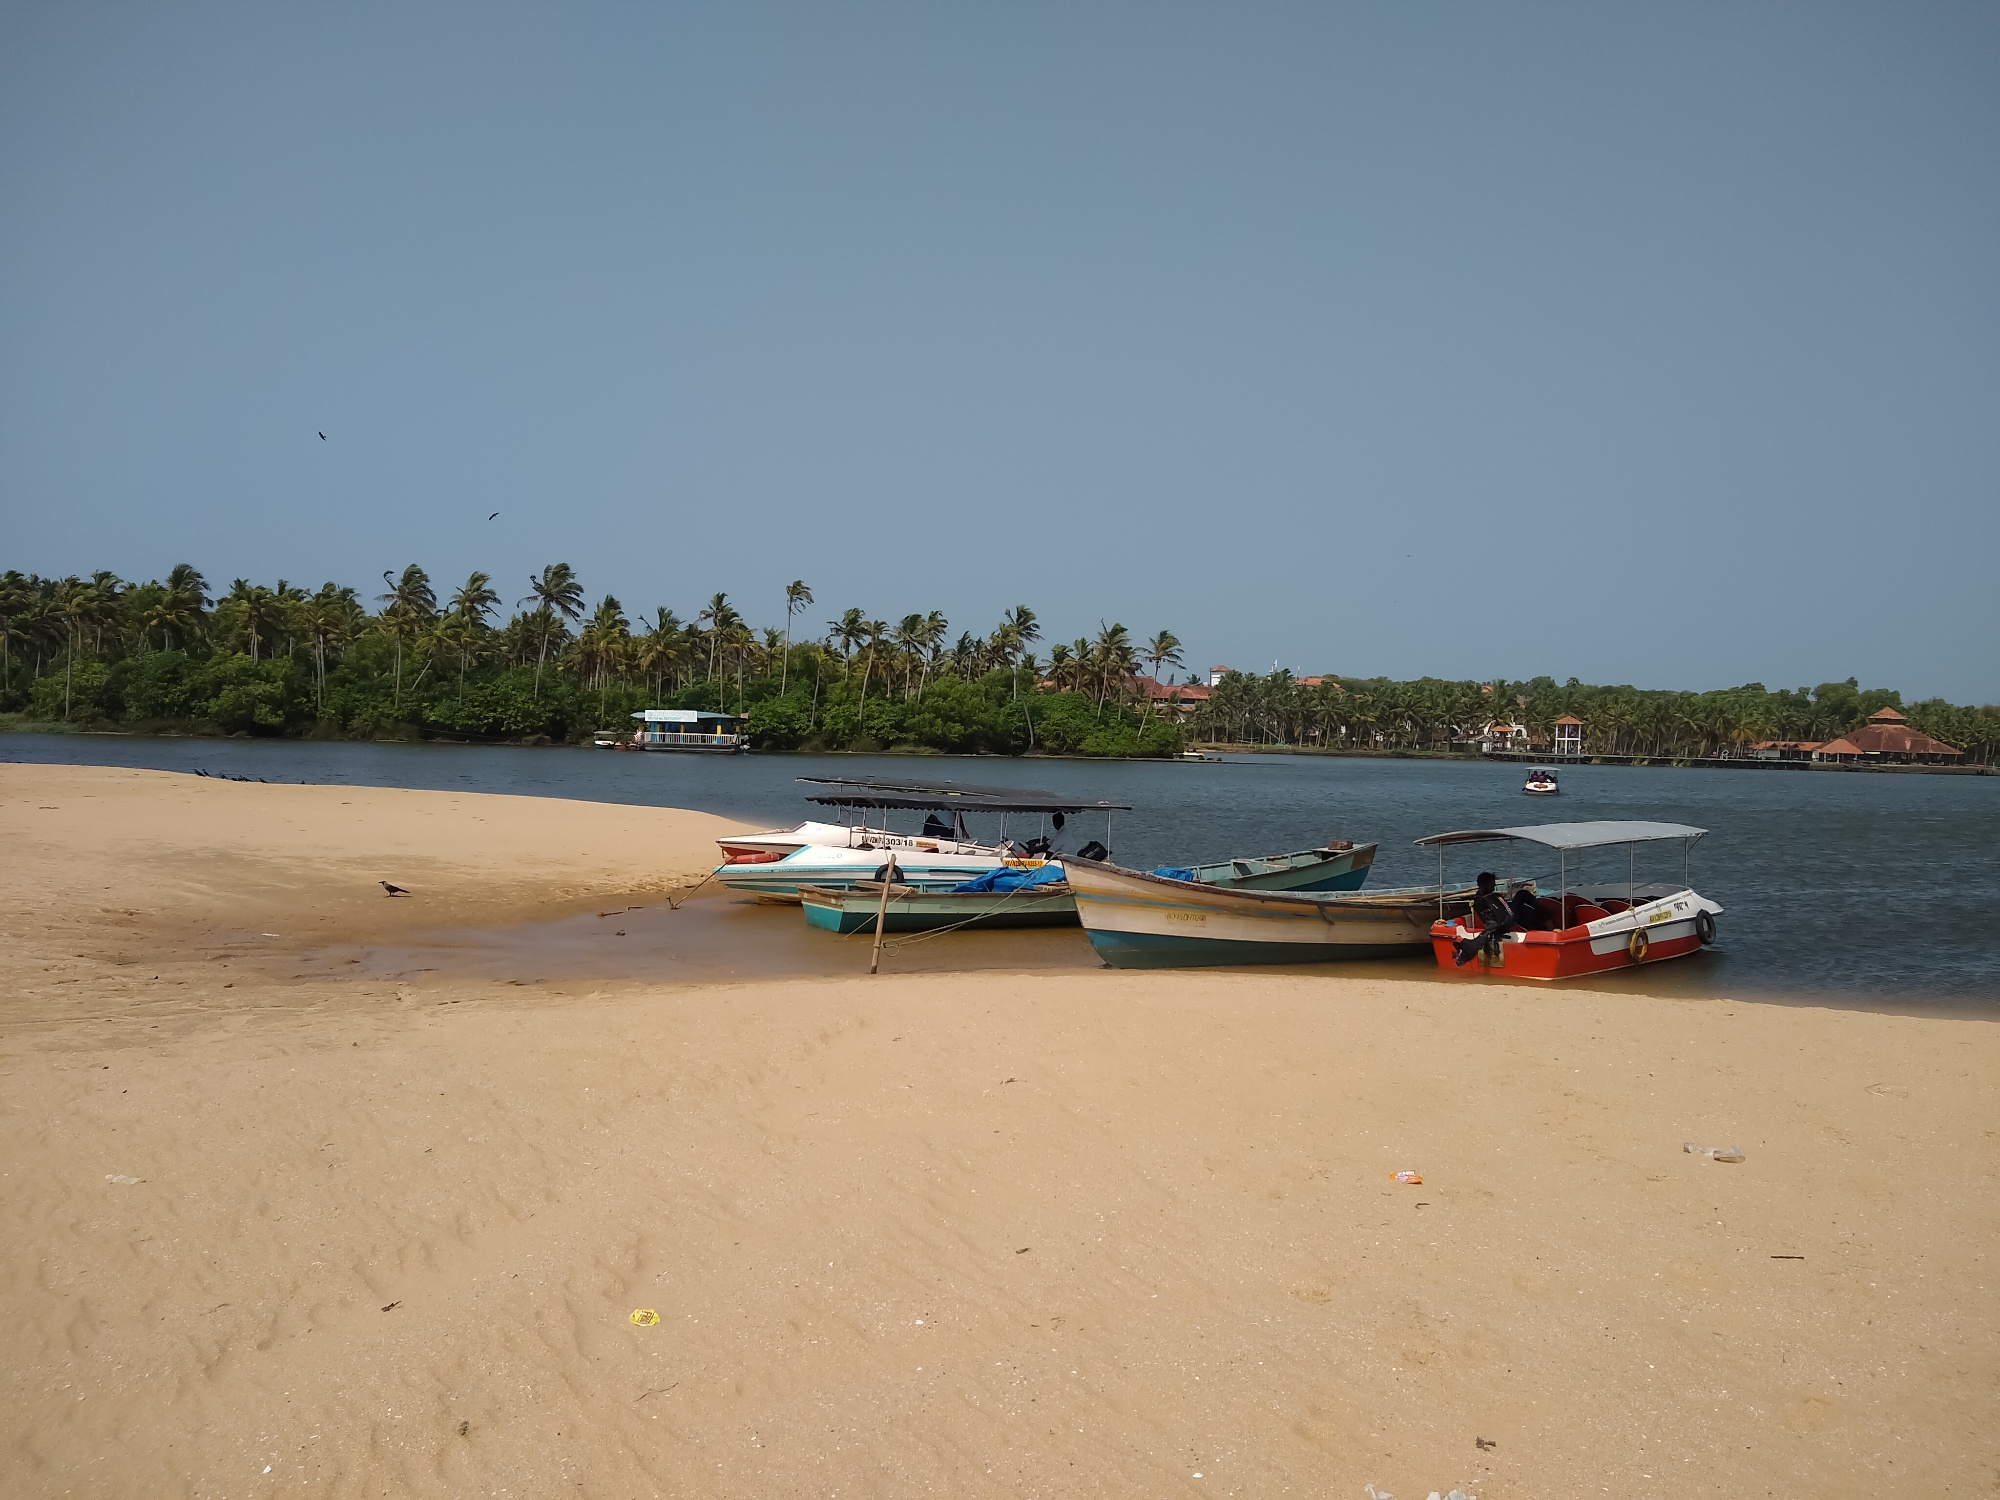Imagine this beach in the future. In the future, this beach might experience significant changes influenced by both human activity and environmental factors. As local tourism potentially increases, small, eco-friendly resorts and beachside cafes could spring up, offering visitors a rustic yet comfortable experience. The wooden boats might give way to modern, motorized fishing vessels, and the fishing practices could evolve with advancements in technology. However, efforts might be made to preserve the cultural heritage and sustainable practices of the fishing community.

Environmental consciousness could lead to conservation projects, with the palm-fringed coastline being protected and local wildlife thriving as a result. The tranquil beaches might also serve as sites for educational tours, where visitors learn about marine ecosystems and the importance of preserving natural habitats. Despite these changes, the essence of the beach as a place of tranquility and natural beauty would remain, continuing to offer a serene escape for both locals and tourists. Could you write a short story about a child growing up on this beach? Once upon a time, in a quaint coastal village in India, lived a young boy named Aarav. From the early days of his childhood, the beach where his family lived was his playground. His father was a fisherman, and every morning, Aarav would watch with wide-eyed wonder as the boats set off into the horizon, the golden sun casting a warm glow over the sandy shore.

Aarav's favorite time of the day was when the boats returned, laden with the day's catch. The beach came alive with activity, as fishermen unloaded their haul and the local market buzzed with the eager chatter of villagers buying fresh fish. Aarav would dart around, helping where he could, his laughter blending with the sounds of the sea.

As he grew older, Aarav began to accompany his father on his fishing trips. The sea, with its vast, ever-changing moods, became a second home to him. He learned the secrets of the tides, the best times to fish, and the ancient stories the fishermen shared under the starry sky. Aarav's bond with the sea deepened, and with it, his respect for its power and beauty.

One evening, as he sat on the sandy shore watching the sun dip below the horizon, Aarav knew that he was destined to follow in his father's footsteps. The beach, with its gentle waves and the soothing rustle of palm trees, was not just his home; it was a part of his soul. Aarav grew up to become a skilled fisherman, his heart forever tied to the tranquil beach that had shaped his childhood and his dreams. 